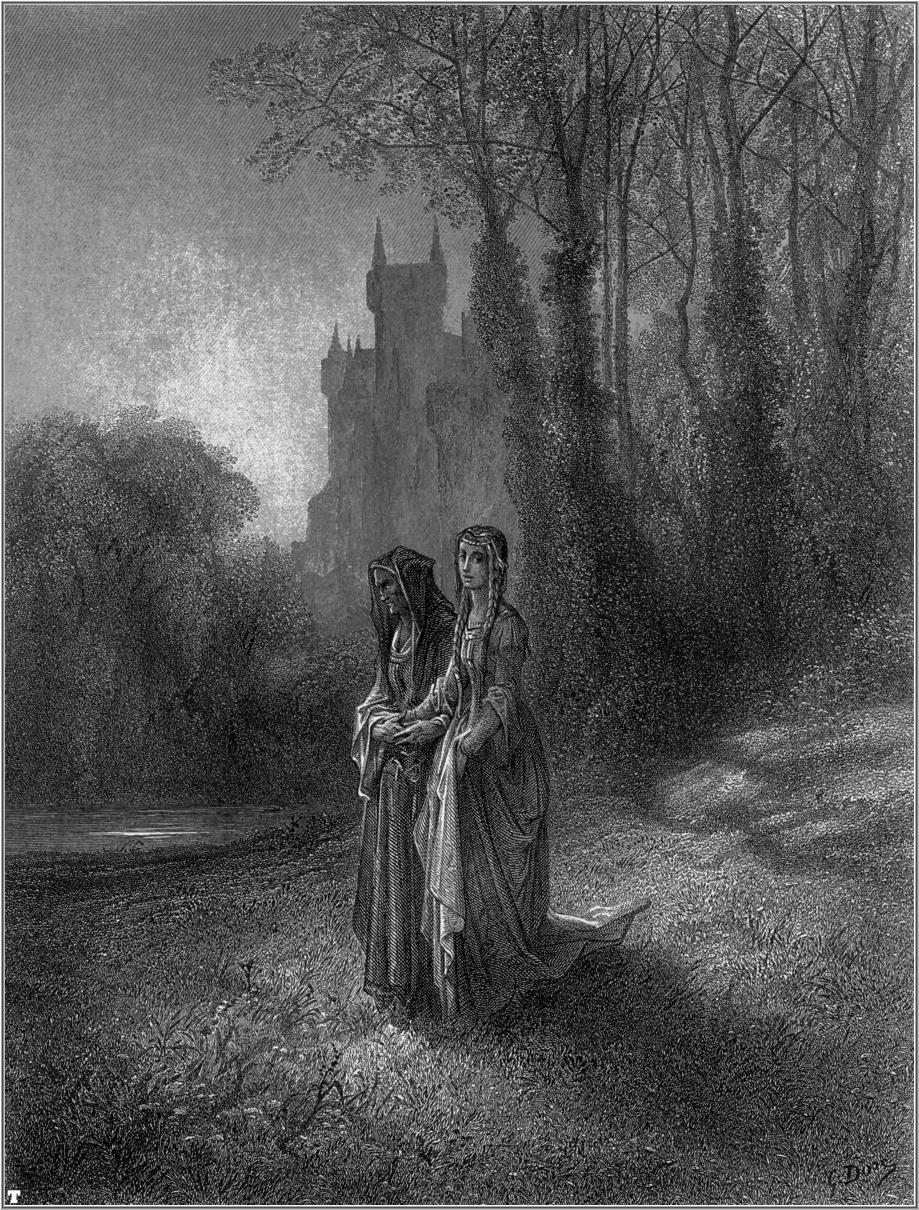Write a vivid description of the castle in the image as if it were at the center of a grand midnight feast. As midnight descends, the castle in the background of the illustration comes alive with the flickering glow of countless lanterns adorning its ancient stone walls. The soft, warm light spills out of the grand windows, casting a golden hue on the towering trees and forest floor below. Inside, the grand hall is buzzing with activity; long tables laden with sumptuous feasts fill the room. Roasted game, fresh bread, and an array of fruits and desserts tempt the revelers, whose laughter and conversations create a harmonious symphony of joy. The air is thick with the aromatic fragrances of spices and herbs, mingling with the sweet scent of blooming flowers adorning the hall. Musicians seated at one end of the hall play lively tunes, their melodies resonating through the castle's ancient stone corridors. Above it all, an ornate chandelier hanging from the vaulted ceiling sparkles with the light of a thousand candles, casting mesmerizing shadows that dance on the walls, bringing the entire scene to life in a timeless celebration of abundance and community. 